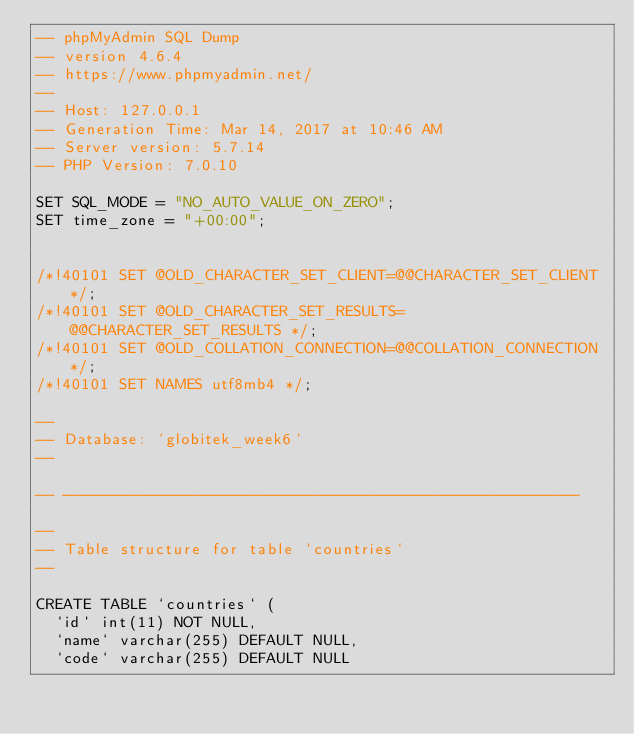<code> <loc_0><loc_0><loc_500><loc_500><_SQL_>-- phpMyAdmin SQL Dump
-- version 4.6.4
-- https://www.phpmyadmin.net/
--
-- Host: 127.0.0.1
-- Generation Time: Mar 14, 2017 at 10:46 AM
-- Server version: 5.7.14
-- PHP Version: 7.0.10

SET SQL_MODE = "NO_AUTO_VALUE_ON_ZERO";
SET time_zone = "+00:00";


/*!40101 SET @OLD_CHARACTER_SET_CLIENT=@@CHARACTER_SET_CLIENT */;
/*!40101 SET @OLD_CHARACTER_SET_RESULTS=@@CHARACTER_SET_RESULTS */;
/*!40101 SET @OLD_COLLATION_CONNECTION=@@COLLATION_CONNECTION */;
/*!40101 SET NAMES utf8mb4 */;

--
-- Database: `globitek_week6`
--

-- --------------------------------------------------------

--
-- Table structure for table `countries`
--

CREATE TABLE `countries` (
  `id` int(11) NOT NULL,
  `name` varchar(255) DEFAULT NULL,
  `code` varchar(255) DEFAULT NULL</code> 